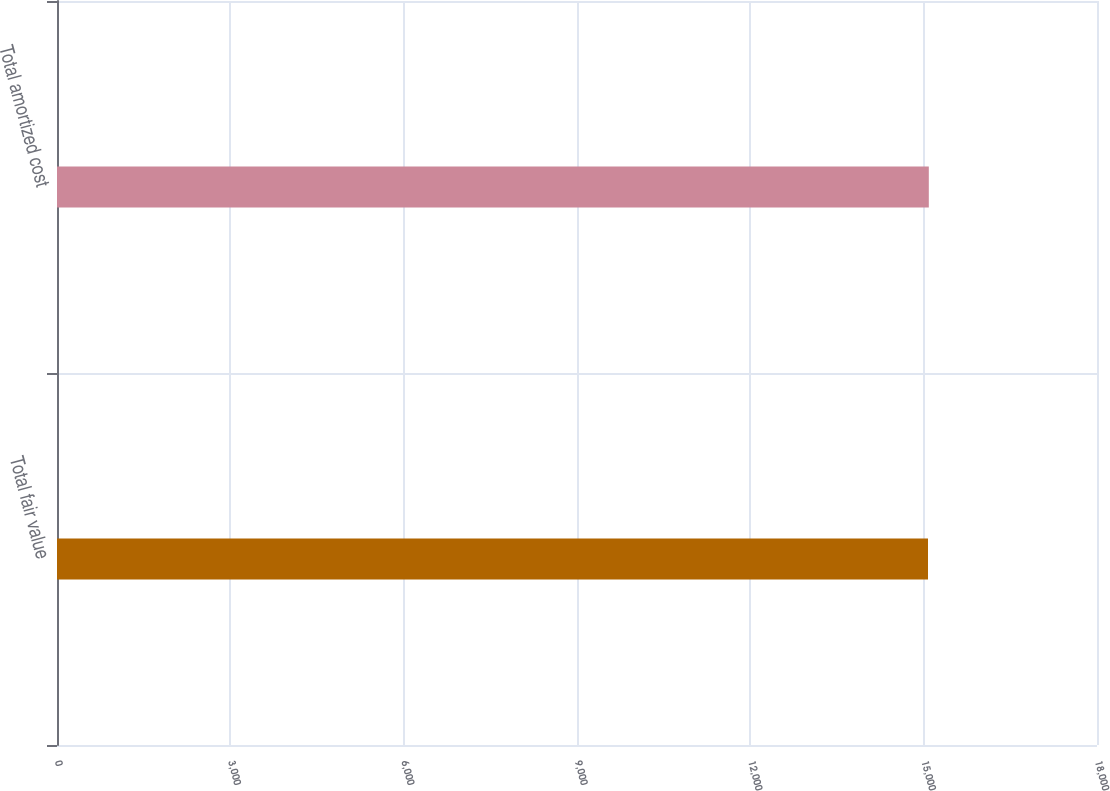Convert chart to OTSL. <chart><loc_0><loc_0><loc_500><loc_500><bar_chart><fcel>Total fair value<fcel>Total amortized cost<nl><fcel>15075<fcel>15089<nl></chart> 